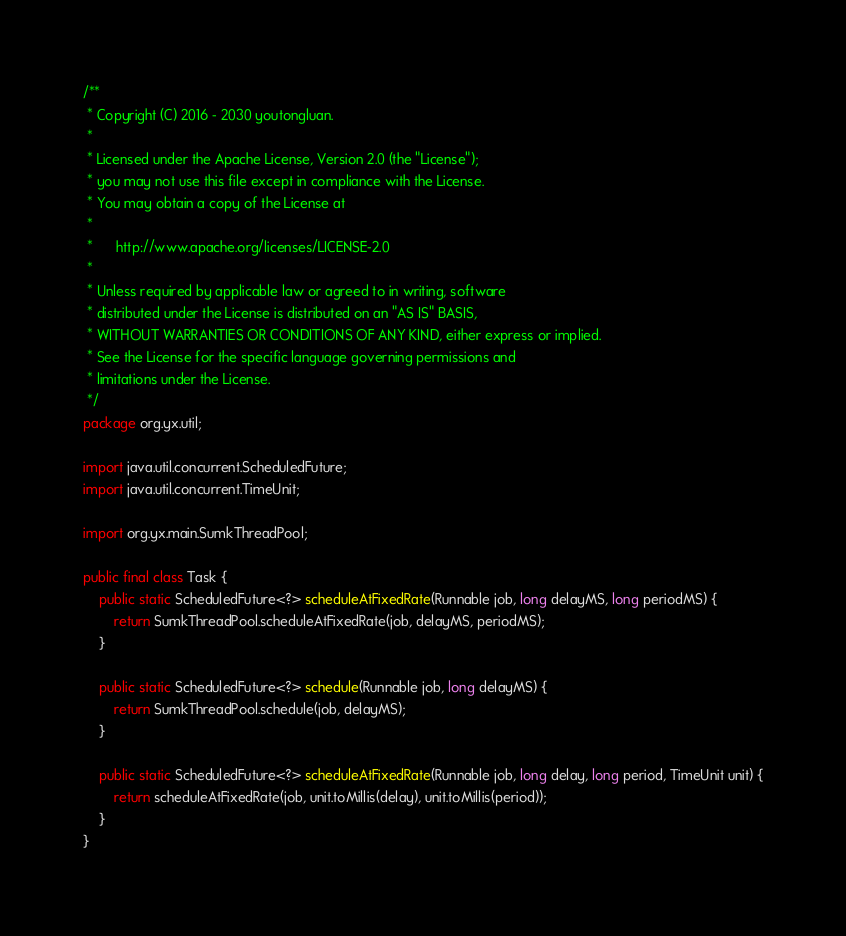<code> <loc_0><loc_0><loc_500><loc_500><_Java_>/**
 * Copyright (C) 2016 - 2030 youtongluan.
 *
 * Licensed under the Apache License, Version 2.0 (the "License");
 * you may not use this file except in compliance with the License.
 * You may obtain a copy of the License at
 *
 * 		http://www.apache.org/licenses/LICENSE-2.0
 *
 * Unless required by applicable law or agreed to in writing, software
 * distributed under the License is distributed on an "AS IS" BASIS,
 * WITHOUT WARRANTIES OR CONDITIONS OF ANY KIND, either express or implied.
 * See the License for the specific language governing permissions and
 * limitations under the License.
 */
package org.yx.util;

import java.util.concurrent.ScheduledFuture;
import java.util.concurrent.TimeUnit;

import org.yx.main.SumkThreadPool;

public final class Task {
	public static ScheduledFuture<?> scheduleAtFixedRate(Runnable job, long delayMS, long periodMS) {
		return SumkThreadPool.scheduleAtFixedRate(job, delayMS, periodMS);
	}

	public static ScheduledFuture<?> schedule(Runnable job, long delayMS) {
		return SumkThreadPool.schedule(job, delayMS);
	}

	public static ScheduledFuture<?> scheduleAtFixedRate(Runnable job, long delay, long period, TimeUnit unit) {
		return scheduleAtFixedRate(job, unit.toMillis(delay), unit.toMillis(period));
	}
}
</code> 